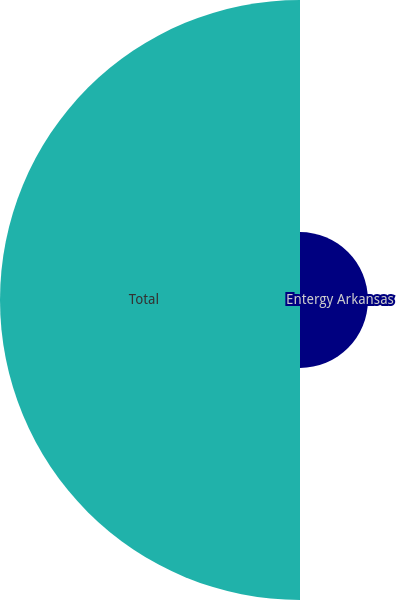<chart> <loc_0><loc_0><loc_500><loc_500><pie_chart><fcel>Entergy Arkansas<fcel>Total<nl><fcel>18.46%<fcel>81.54%<nl></chart> 